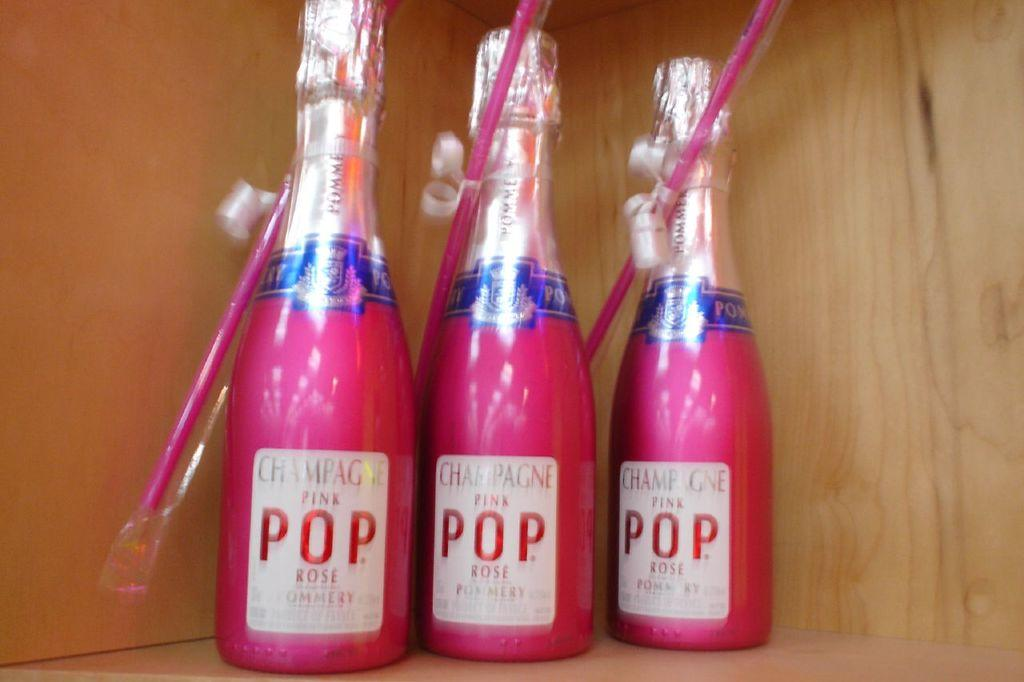<image>
Relay a brief, clear account of the picture shown. 3 pink bottles of pink champagne rose called Pop 